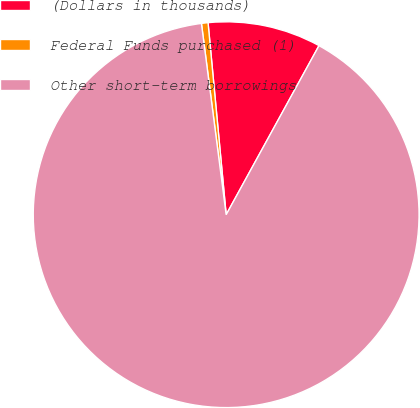<chart> <loc_0><loc_0><loc_500><loc_500><pie_chart><fcel>(Dollars in thousands)<fcel>Federal Funds purchased (1)<fcel>Other short-term borrowings<nl><fcel>9.49%<fcel>0.55%<fcel>89.97%<nl></chart> 